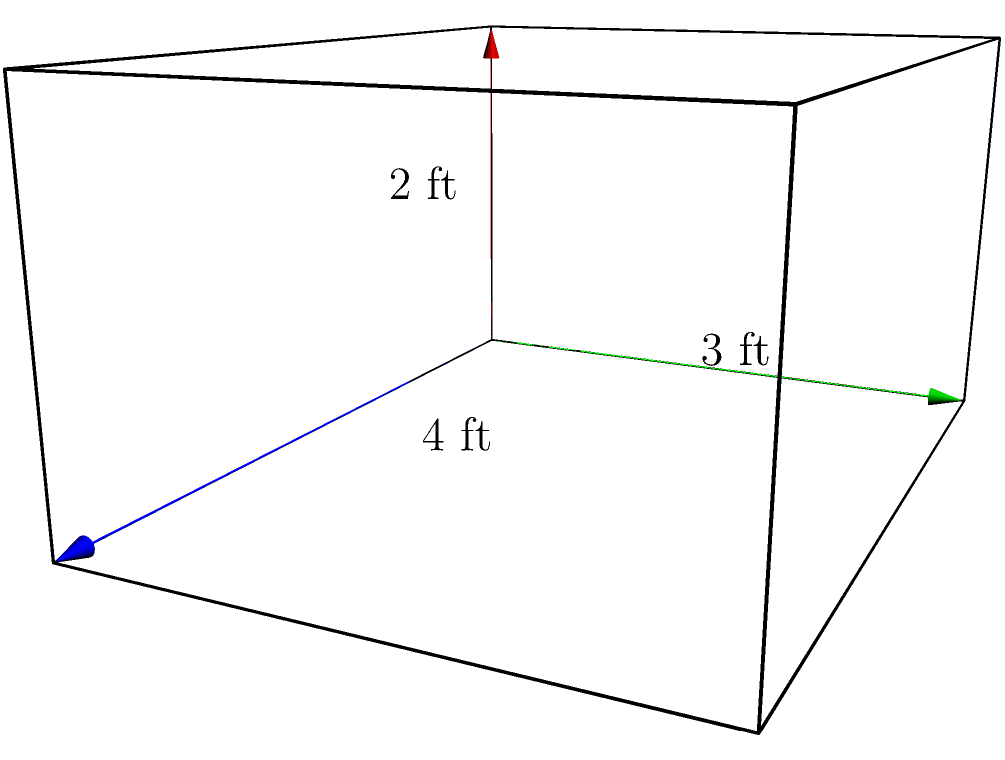As a karate instructor, you need to calculate the volume of a new equipment storage locker for your dojo. The locker is shaped like a rectangular prism with dimensions 4 feet in length, 3 feet in width, and 2 feet in height. What is the volume of the locker in cubic feet? To calculate the volume of a rectangular prism, we use the formula:

$$V = l \times w \times h$$

Where:
$V$ = volume
$l$ = length
$w$ = width
$h$ = height

Given dimensions:
Length ($l$) = 4 feet
Width ($w$) = 3 feet
Height ($h$) = 2 feet

Let's substitute these values into the formula:

$$V = 4 \text{ ft} \times 3 \text{ ft} \times 2 \text{ ft}$$

Multiplying these numbers:

$$V = 24 \text{ ft}^3$$

Therefore, the volume of the equipment storage locker is 24 cubic feet.
Answer: $24 \text{ ft}^3$ 